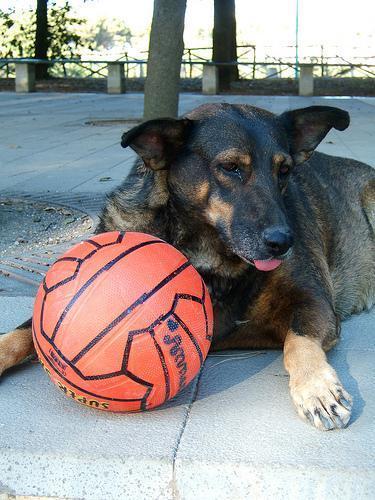How many dogs are there?
Give a very brief answer. 1. 